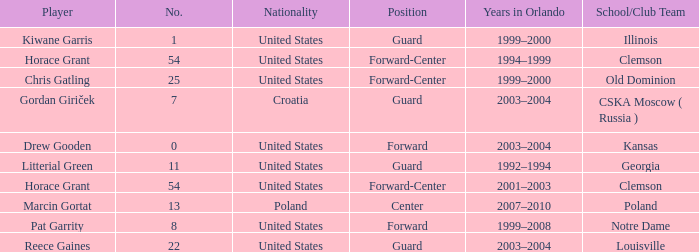What is Chris Gatling 's number? 25.0. 